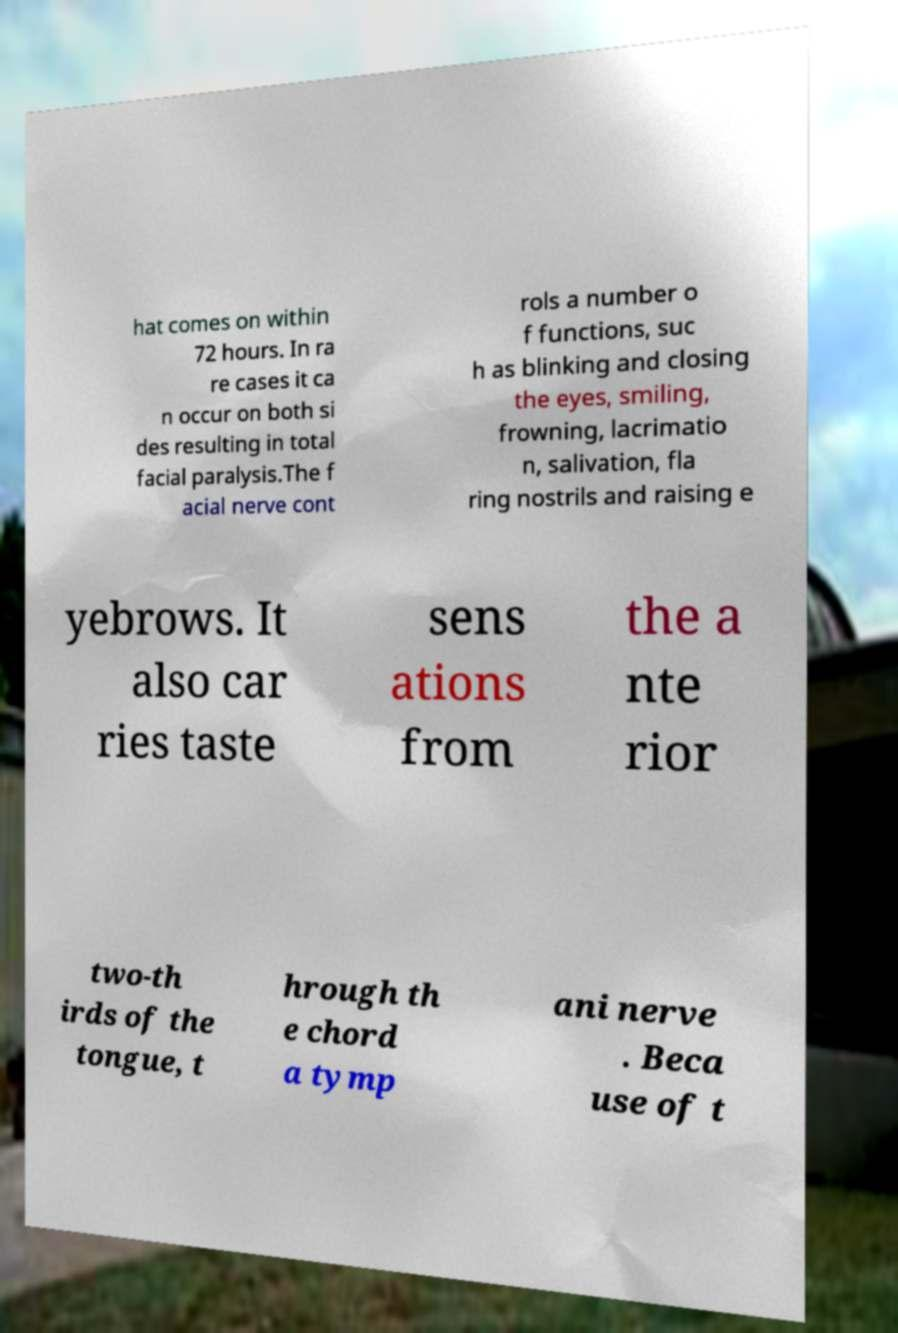Please identify and transcribe the text found in this image. hat comes on within 72 hours. In ra re cases it ca n occur on both si des resulting in total facial paralysis.The f acial nerve cont rols a number o f functions, suc h as blinking and closing the eyes, smiling, frowning, lacrimatio n, salivation, fla ring nostrils and raising e yebrows. It also car ries taste sens ations from the a nte rior two-th irds of the tongue, t hrough th e chord a tymp ani nerve . Beca use of t 